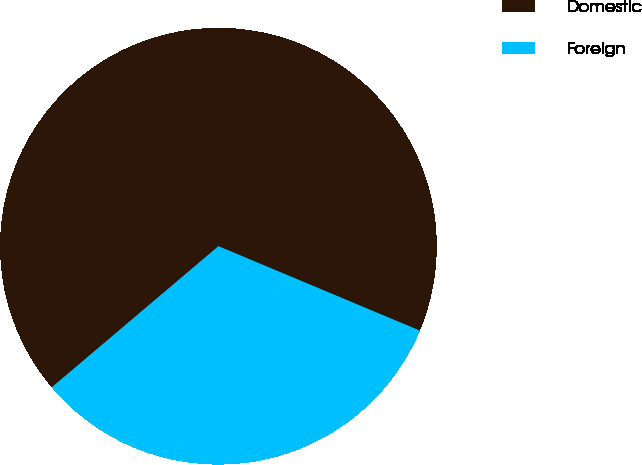Convert chart to OTSL. <chart><loc_0><loc_0><loc_500><loc_500><pie_chart><fcel>Domestic<fcel>Foreign<nl><fcel>67.5%<fcel>32.5%<nl></chart> 